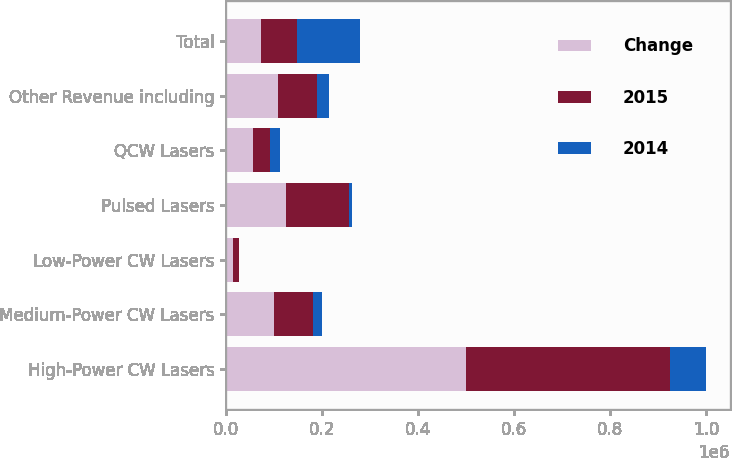Convert chart to OTSL. <chart><loc_0><loc_0><loc_500><loc_500><stacked_bar_chart><ecel><fcel>High-Power CW Lasers<fcel>Medium-Power CW Lasers<fcel>Low-Power CW Lasers<fcel>Pulsed Lasers<fcel>QCW Lasers<fcel>Other Revenue including<fcel>Total<nl><fcel>Change<fcel>499643<fcel>99452<fcel>13761<fcel>124824<fcel>56506<fcel>107079<fcel>73569<nl><fcel>2015<fcel>426074<fcel>80971<fcel>13174<fcel>131593<fcel>34881<fcel>83139<fcel>73569<nl><fcel>2014<fcel>73569<fcel>18481<fcel>587<fcel>6769<fcel>21625<fcel>23940<fcel>131433<nl></chart> 